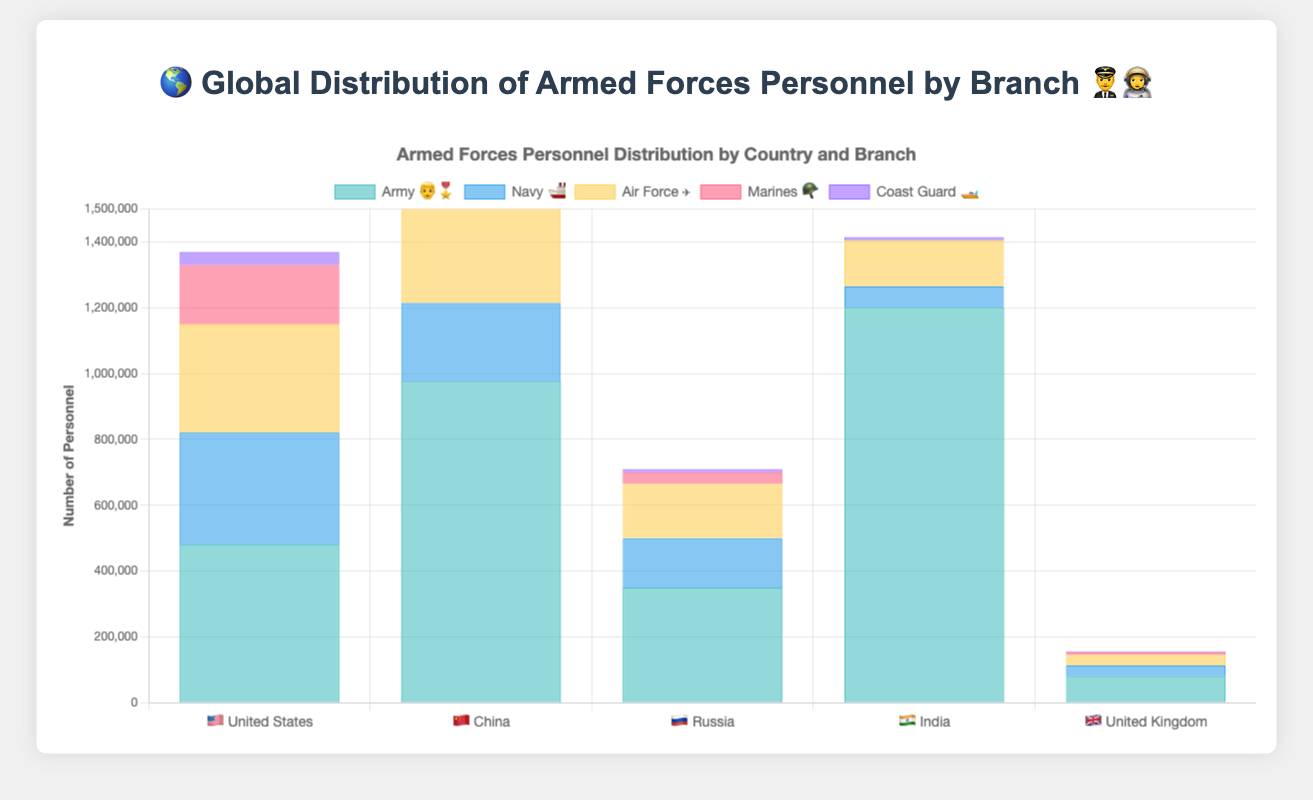what is the total number of personnel in the United States' armed forces? 🇺🇸 Sum the number of personnel in each branch for the United States: 480,000 (Army) + 340,000 (Navy) + 330,000 (Air Force) + 180,000 (Marines) + 40,000 (Coast Guard) = 1,370,000
Answer: 1,370,000 Which country has the largest army? Compare the number of army personnel among the five countries: China (975,000), followed by the United States (480,000), Russia (350,000), India (1,200,000), and the United Kingdom (80,000), is the highest.
Answer: 🇮🇳 India What is the combined number of Navy personnel in China and Russia? 🚢 Add the number of Navy personnel in China and Russia: 240,000 (China) + 150,000 (Russia) = 390,000
Answer: 390,000 Which branch has the least number of personnel in India? 🇮🇳 Compare the personnel numbers for all branches in India: 1,200,000 (Army), 65,000 (Navy), 140,000 (Air Force), 0 (Marines), and 10,000 (Coast Guard). The Marines have the least with 0 personnel.
Answer: Marines How many Marines are there in total across all listed countries? 🪖 Sum the number of Marines in each country: 180,000 (United States) + 25,000 (China) + 35,000 (Russia) + 0 (India) + 7,000 (United Kingdom) = 247,000
Answer: 247,000 Which country has the highest number of Air Force personnel? ✈️ Compare the Air Force personnel numbers: United States (330,000), China (395,000), Russia (165,000), India (140,000), and the United Kingdom (33,000). China has the highest with 395,000.
Answer: 🇨🇳 China What is the difference in Army personnel between India and the United States? Subtract the number of Army personnel in the United States from India's number: 1,200,000 (India) - 480,000 (United States) = 720,000
Answer: 720,000 How does the number of personnel in the UK's Coast Guard compare to China's Coast Guard? 🚤 Compare the Coast Guard personnel numbers: United Kingdom (3,500) vs. China (15,000). The United Kingdom has fewer Coast Guard personnel.
Answer: Fewer What is the average number of Army personnel across all listed countries? 👨‍🎖️ Sum the Army personnel numbers for all countries and divide by the number of countries: (480,000 (United States) + 975,000 (China) + 350,000 (Russia) + 1,200,000 (India) + 80,000 (United Kingdom)) / 5 = 3,085,000 / 5 = 617,000
Answer: 617,000 